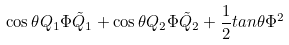Convert formula to latex. <formula><loc_0><loc_0><loc_500><loc_500>\cos \theta Q _ { 1 } \Phi \tilde { Q } _ { 1 } + \cos \theta Q _ { 2 } \Phi \tilde { Q } _ { 2 } + \frac { 1 } { 2 } t a n { \theta } \Phi ^ { 2 }</formula> 